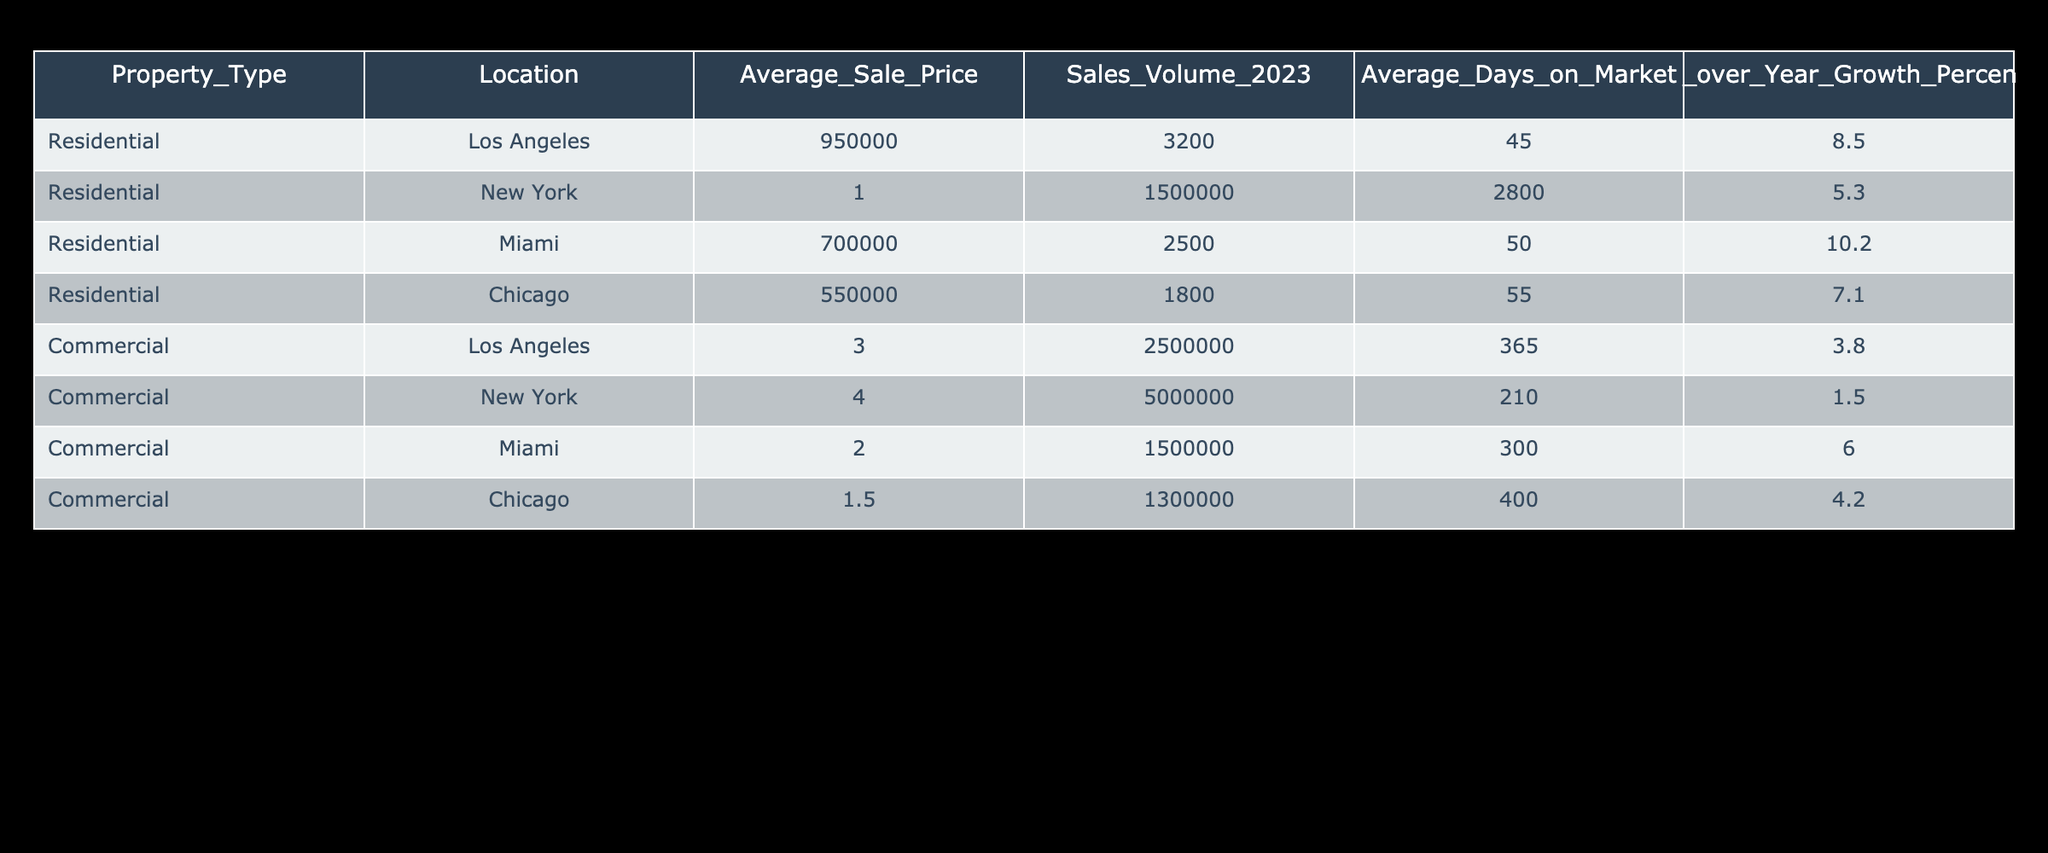What is the average sale price of residential properties in New York? The average sale price of residential properties in New York is given directly in the table as 1,500,000.
Answer: 1,500,000 Which location has the highest sales volume for commercial properties? By looking at the sales volume column for commercial properties, New York has the highest sales volume at 5,000,000.
Answer: New York What is the average days on market for residential properties in Miami? The average days on market for residential properties in Miami is listed in the table as 50 days.
Answer: 50 What is the total sales volume for all residential properties? To find the total sales volume for residential properties, we sum the sales volumes: 3200 + 2800 + 2500 + 1800 = 10300.
Answer: 10300 Do commercial properties in Los Angeles have a higher average sale price than those in Miami? The average sale price for commercial properties in Los Angeles is 3,000,000 and for Miami is 2,000,000; therefore, the average sale price in Los Angeles is higher.
Answer: Yes What is the year-over-year growth percentage difference between residential properties in Chicago and commercial properties in Chicago? The year-over-year growth percentage for residential properties in Chicago is 7.1% and for commercial properties is 4.2%. The difference is 7.1 - 4.2 = 2.9%.
Answer: 2.9% Which property type had a lower average sale price, residential or commercial in Miami? The average sale price for residential in Miami is 700,000, while for commercial it is 2,000,000; thus, residential has the lower average sale price.
Answer: Residential What is the ratio of sales volume of commercial properties to residential properties in Los Angeles? The sales volume for commercial properties in Los Angeles is 2,500,000, while for residential it is 3,200. The ratio is 2,500,000 / 3,200 = 781.25.
Answer: 781.25 